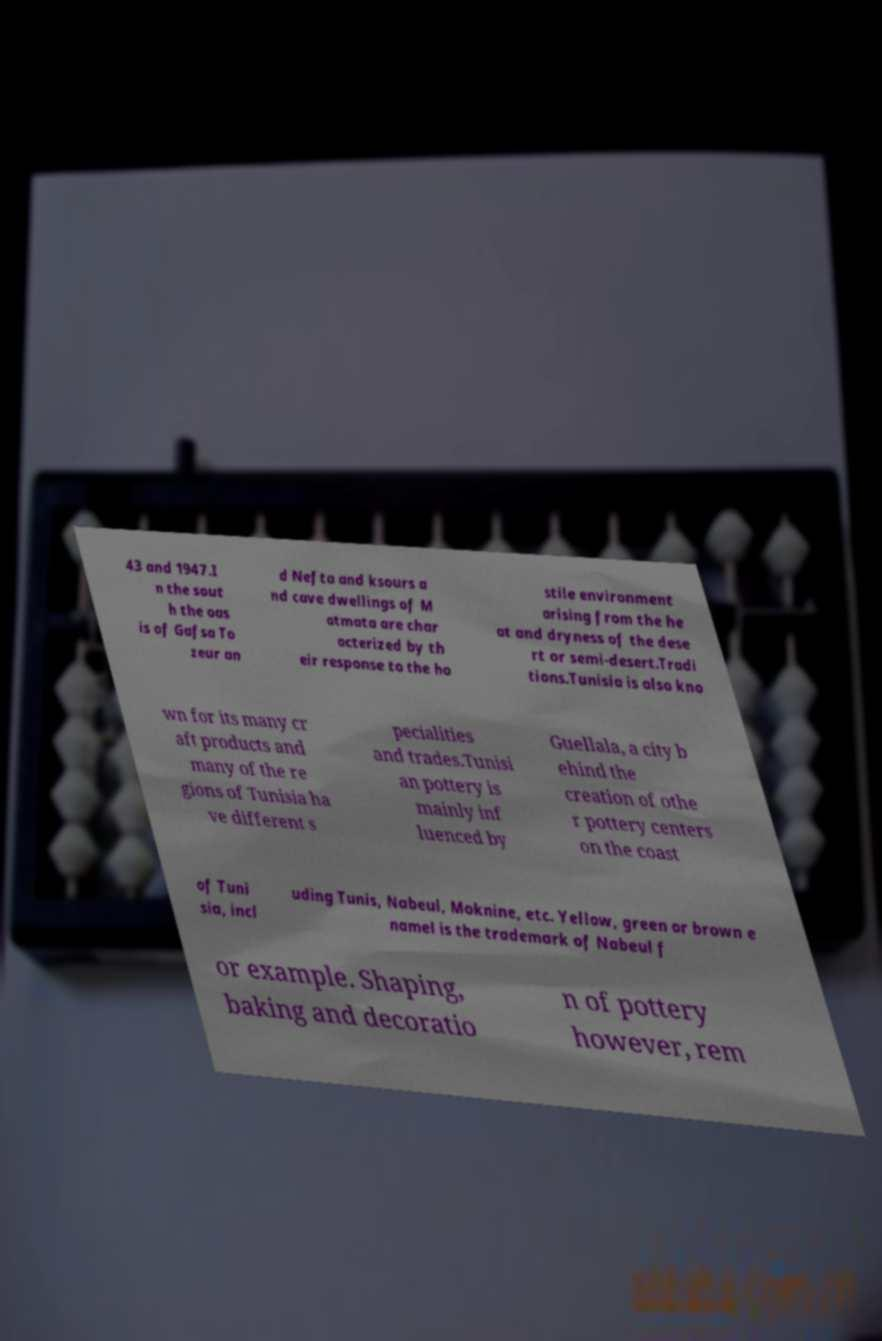Please identify and transcribe the text found in this image. 43 and 1947.I n the sout h the oas is of Gafsa To zeur an d Nefta and ksours a nd cave dwellings of M atmata are char acterized by th eir response to the ho stile environment arising from the he at and dryness of the dese rt or semi-desert.Tradi tions.Tunisia is also kno wn for its many cr aft products and many of the re gions of Tunisia ha ve different s pecialities and trades.Tunisi an pottery is mainly inf luenced by Guellala, a city b ehind the creation of othe r pottery centers on the coast of Tuni sia, incl uding Tunis, Nabeul, Moknine, etc. Yellow, green or brown e namel is the trademark of Nabeul f or example. Shaping, baking and decoratio n of pottery however, rem 